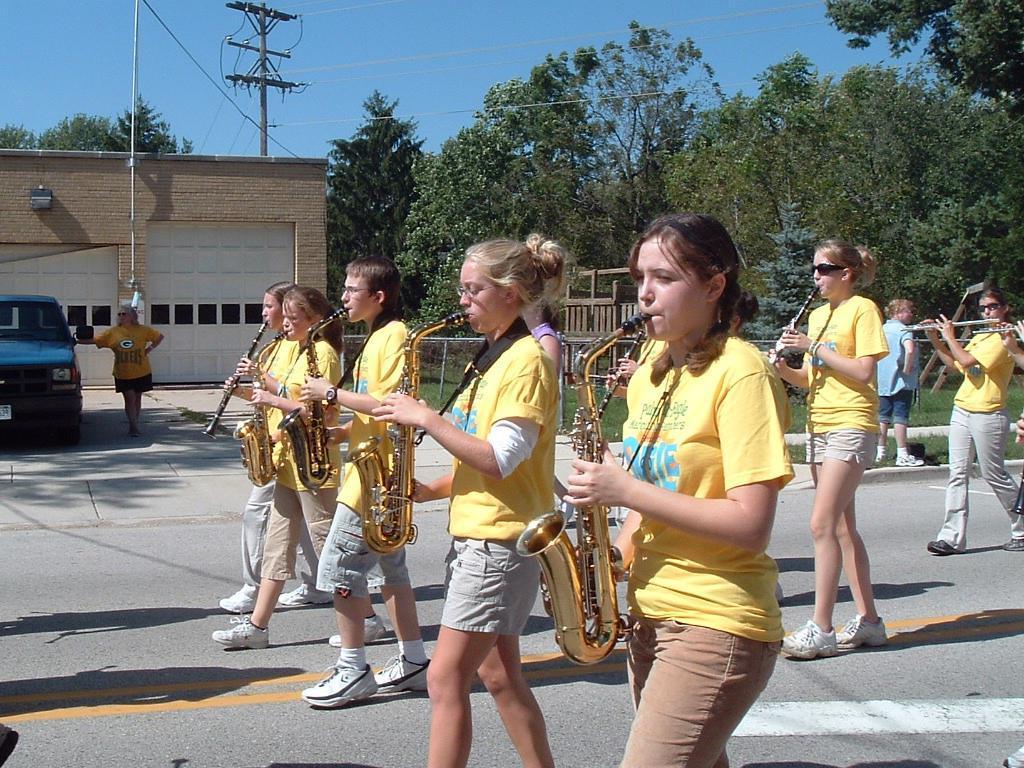Could you give a brief overview of what you see in this image? In this picture I can see a building and a car and I can see a woman standing and I can see trees and few women are playing musical instruments and walking on the road and I can see another woman standing in the back and I can see blue sky and couple of poles and I can see grass on the ground. 